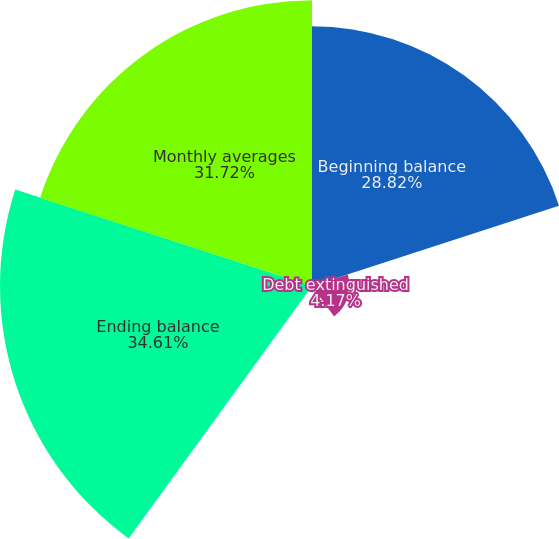Convert chart to OTSL. <chart><loc_0><loc_0><loc_500><loc_500><pie_chart><fcel>Beginning balance<fcel>Debt extinguished<fcel>Principal payments<fcel>Ending balance<fcel>Monthly averages<nl><fcel>28.82%<fcel>4.17%<fcel>0.68%<fcel>34.62%<fcel>31.72%<nl></chart> 